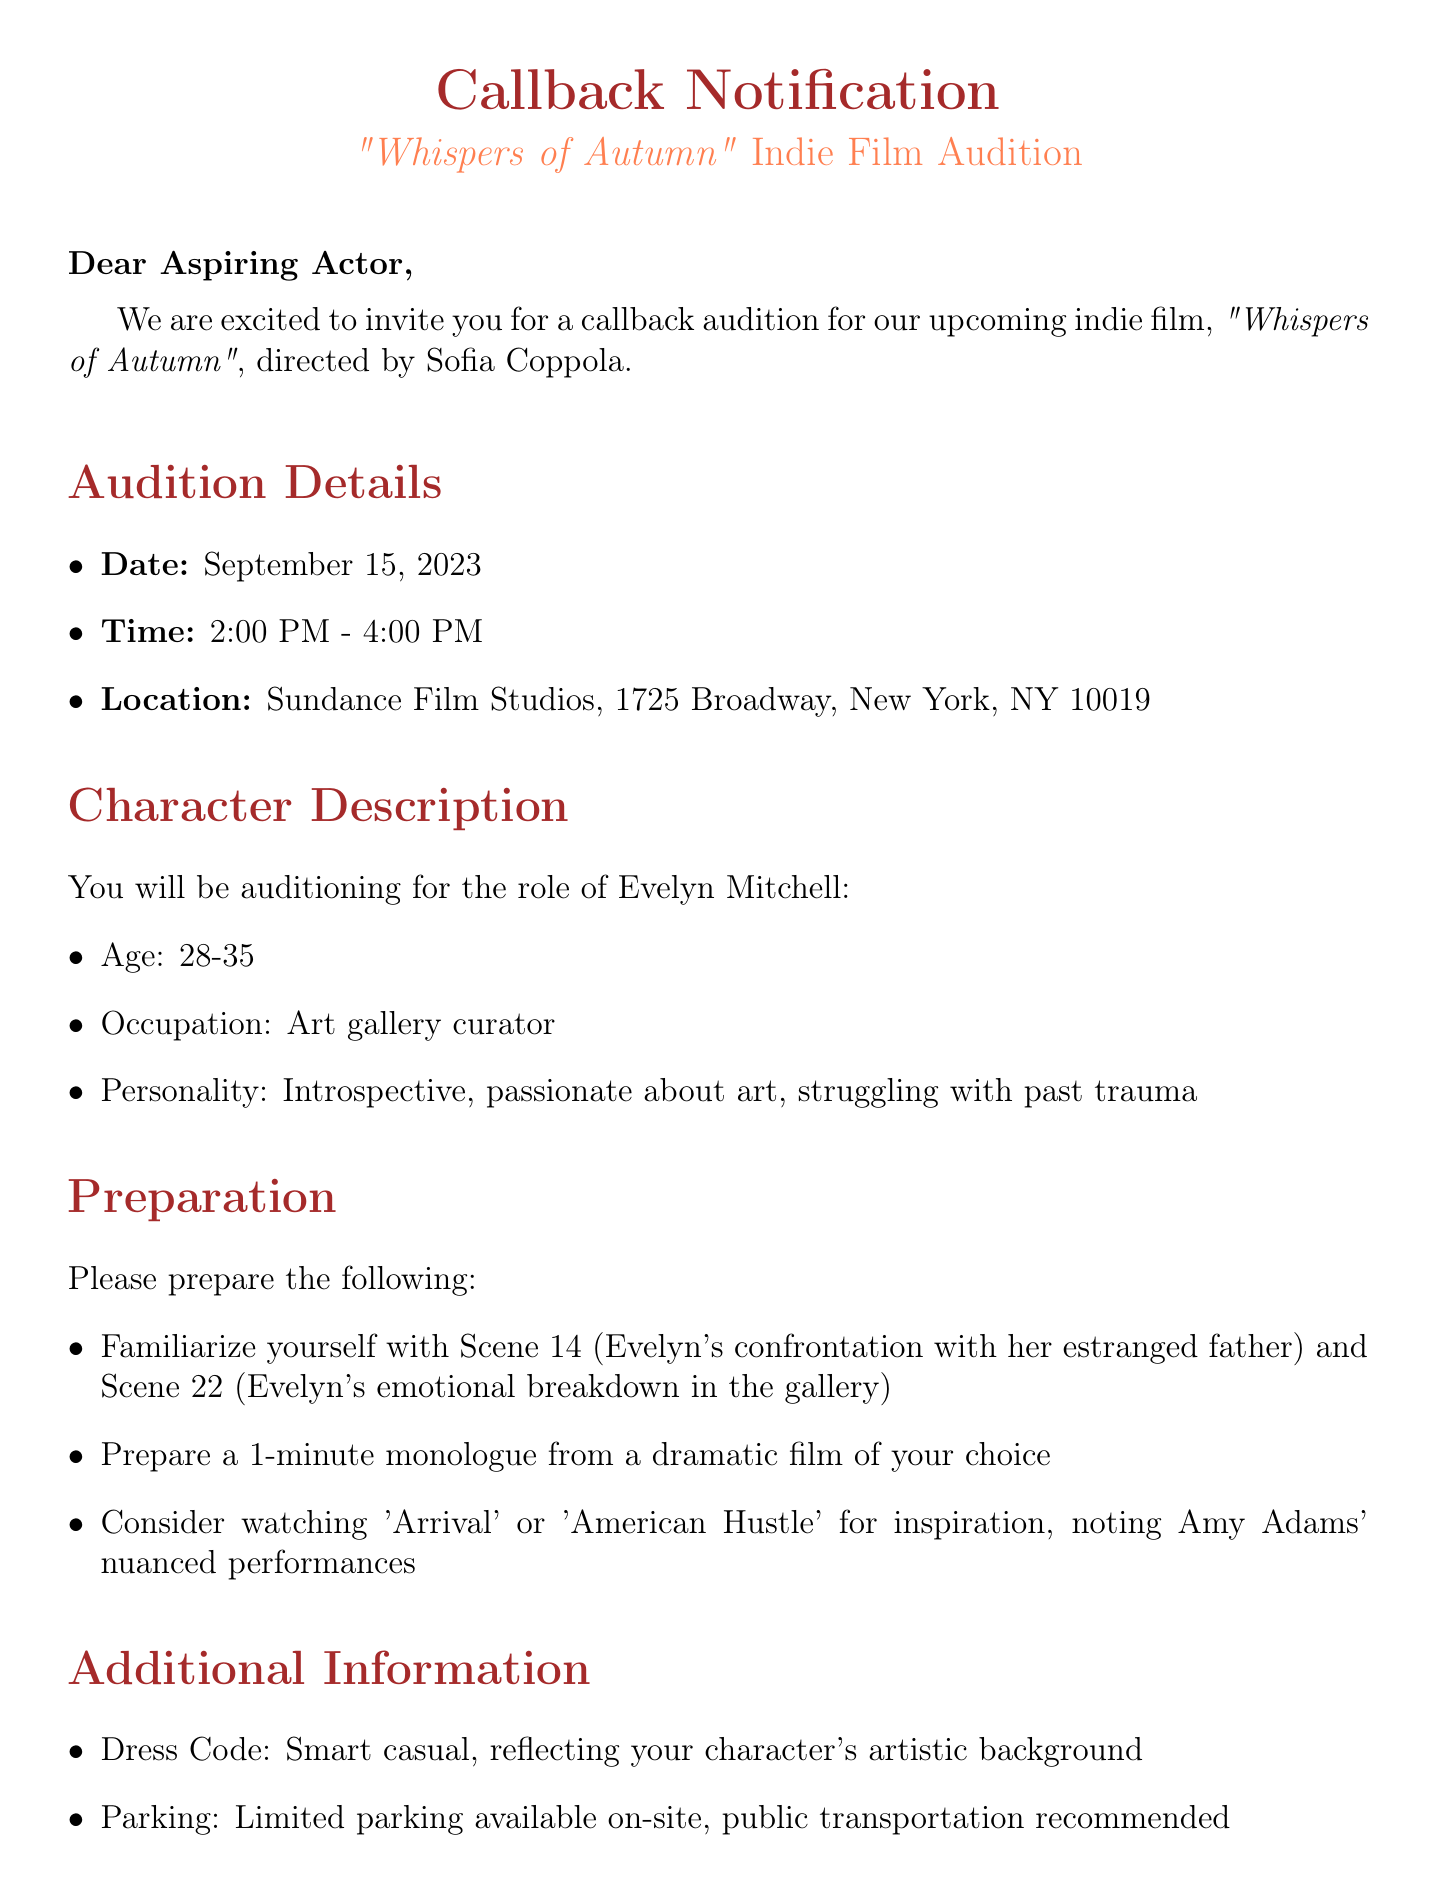what is the title of the film? The title of the film is mentioned in the document as "Whispers of Autumn."
Answer: Whispers of Autumn who is the director of the film? The director of the film is stated in the document as Sofia Coppola.
Answer: Sofia Coppola what is the date of the callback? The date of the callback is provided as September 15, 2023.
Answer: September 15, 2023 what character is being auditioned for? The character being auditioned for is named Evelyn Mitchell.
Answer: Evelyn Mitchell what is the dress code for the audition? The dress code specified in the document is described as smart casual.
Answer: Smart casual how many scenes should be prepared? The document indicates two scenes to prepare for the audition.
Answer: Two scenes what emotions should the actor convey in Scene 22? Scene 22 involves an emotional breakdown, suggesting that the actor should convey deep emotions.
Answer: Emotional breakdown how long should the prepared monologue be? The document specifies that the monologue should be 1 minute long.
Answer: 1 minute who should be contacted for further questions? The contact person listed for further questions is Rachel Martinez.
Answer: Rachel Martinez 